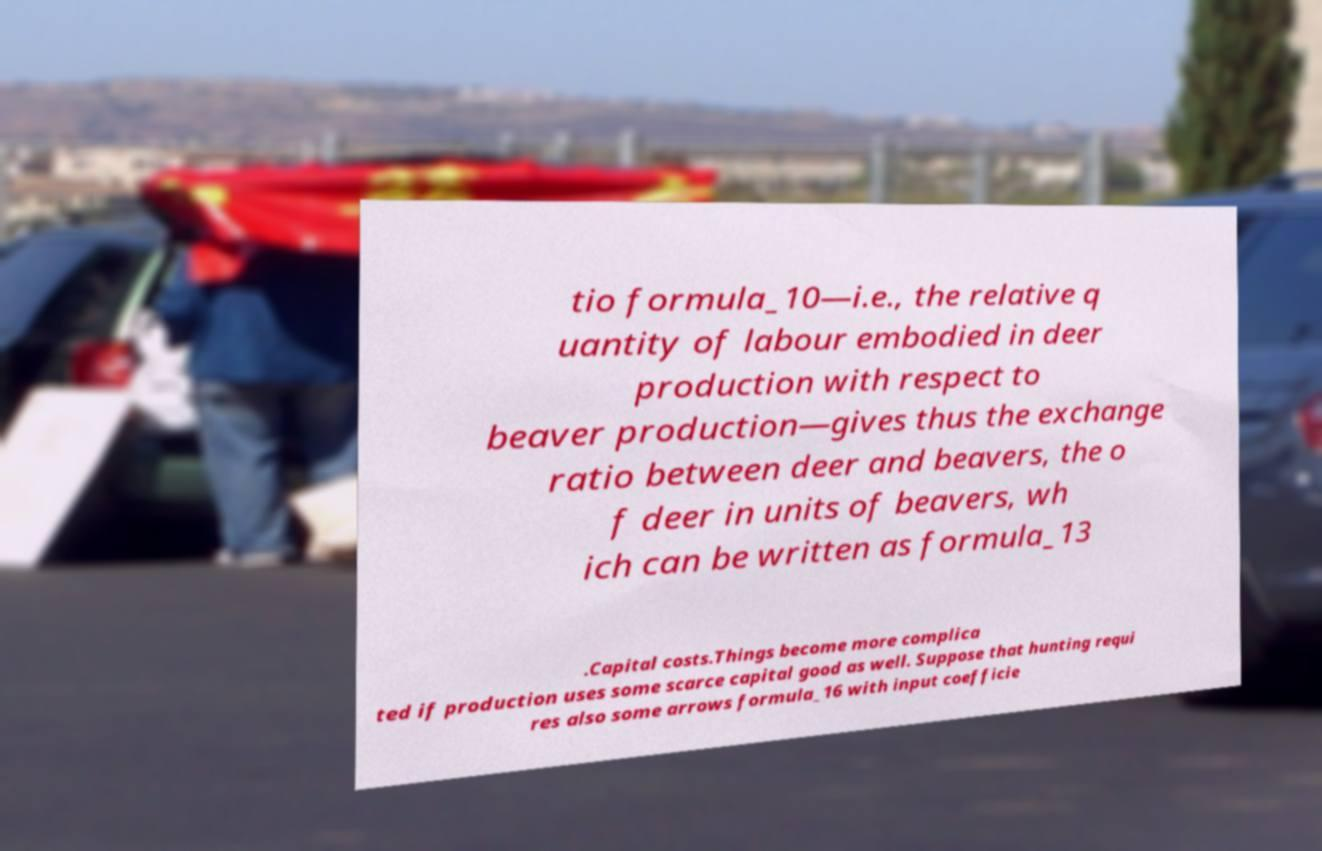Can you accurately transcribe the text from the provided image for me? tio formula_10—i.e., the relative q uantity of labour embodied in deer production with respect to beaver production—gives thus the exchange ratio between deer and beavers, the o f deer in units of beavers, wh ich can be written as formula_13 .Capital costs.Things become more complica ted if production uses some scarce capital good as well. Suppose that hunting requi res also some arrows formula_16 with input coefficie 